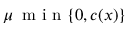<formula> <loc_0><loc_0><loc_500><loc_500>\mu \, m i n \{ 0 , c ( x ) \}</formula> 